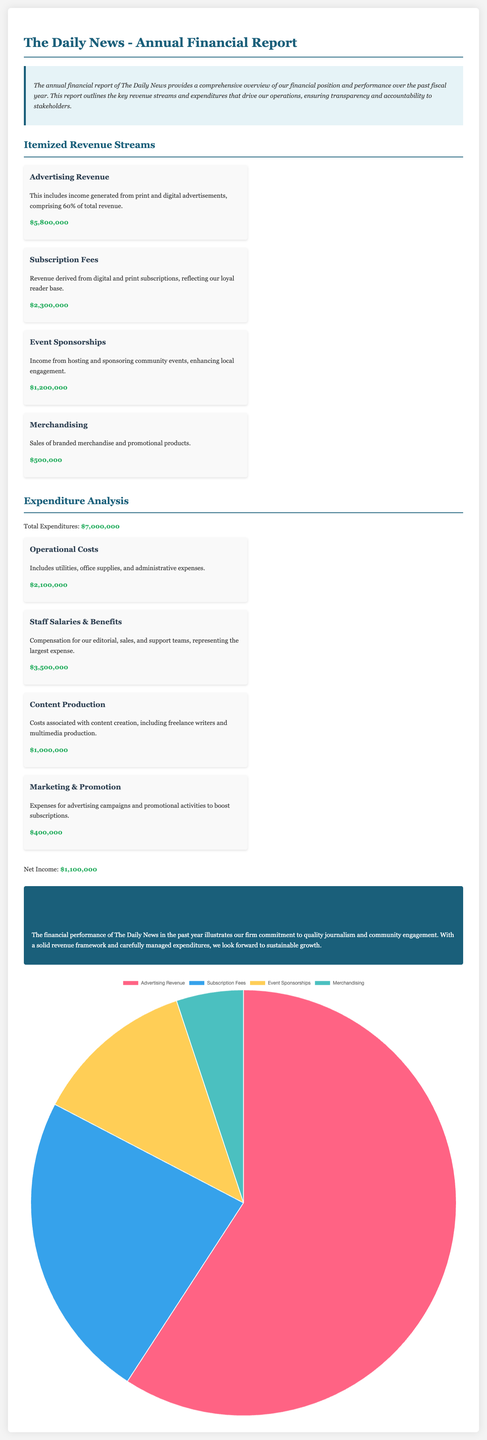What is the total revenue from advertising? The document states that the advertising revenue is $5,800,000.
Answer: $5,800,000 What percentage of total revenue comes from advertising? The advertising revenue comprises 60% of total revenue as indicated in the document.
Answer: 60% What are the total expenditures? The document specifies that total expenditures amount to $7,000,000.
Answer: $7,000,000 What is the net income for the fiscal year? The net income is stated to be $1,100,000 in the document.
Answer: $1,100,000 What expense category has the highest cost? The largest expense is for staff salaries and benefits, as indicated in the expenditure analysis section.
Answer: Staff Salaries & Benefits How much revenue is generated from event sponsorships? The document mentions that event sponsorships generate $1,200,000 in revenue.
Answer: $1,200,000 What is the total amount from subscription fees? The document states that subscription fees total $2,300,000.
Answer: $2,300,000 What type of expenses are classified under operational costs? The operational costs include utilities, office supplies, and administrative expenses according to the document.
Answer: Utilities, office supplies, and administrative expenses What is the total amount allocated for marketing and promotion? The document indicates that marketing and promotion expenses are $400,000.
Answer: $400,000 